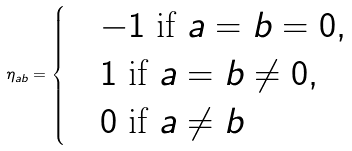Convert formula to latex. <formula><loc_0><loc_0><loc_500><loc_500>\eta _ { a b } = \begin{cases} & - 1 \text {  if $a=b=0$} , \\ & 1 \text {  if $a=b\neq 0$} , \\ & 0 \text {  if $a \neq b$} \end{cases}</formula> 